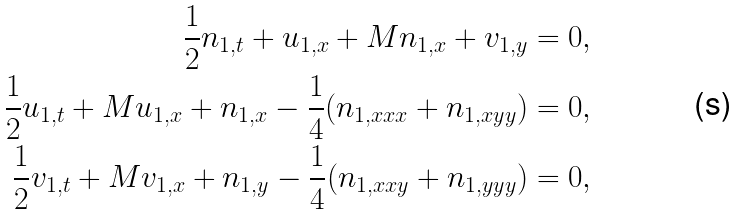Convert formula to latex. <formula><loc_0><loc_0><loc_500><loc_500>\frac { 1 } { 2 } n _ { 1 , t } + u _ { 1 , x } + M n _ { 1 , x } + v _ { 1 , y } = 0 , \\ \frac { 1 } { 2 } u _ { 1 , t } + M u _ { 1 , x } + n _ { 1 , x } - \frac { 1 } { 4 } ( n _ { 1 , x x x } + n _ { 1 , x y y } ) = 0 , \\ \frac { 1 } { 2 } v _ { 1 , t } + M v _ { 1 , x } + n _ { 1 , y } - \frac { 1 } { 4 } ( n _ { 1 , x x y } + n _ { 1 , y y y } ) = 0 ,</formula> 